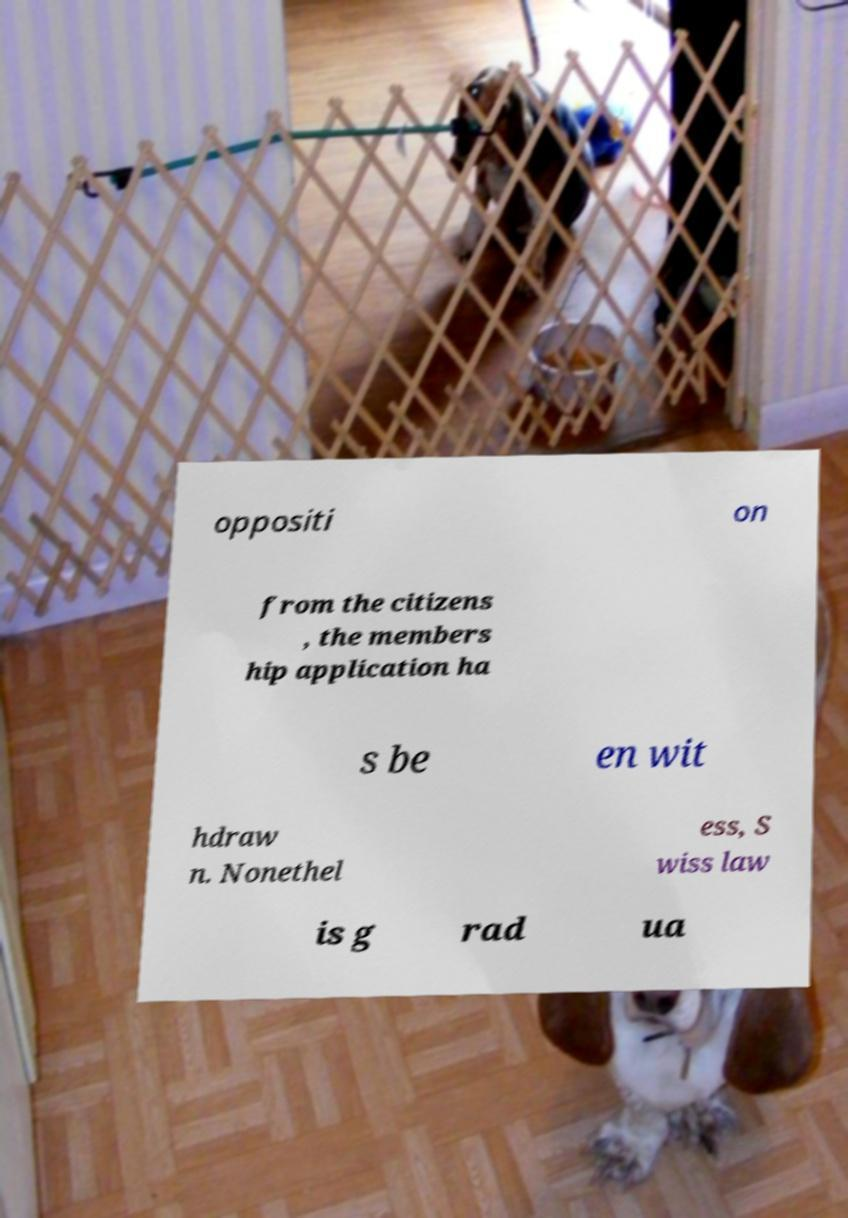Please read and relay the text visible in this image. What does it say? oppositi on from the citizens , the members hip application ha s be en wit hdraw n. Nonethel ess, S wiss law is g rad ua 